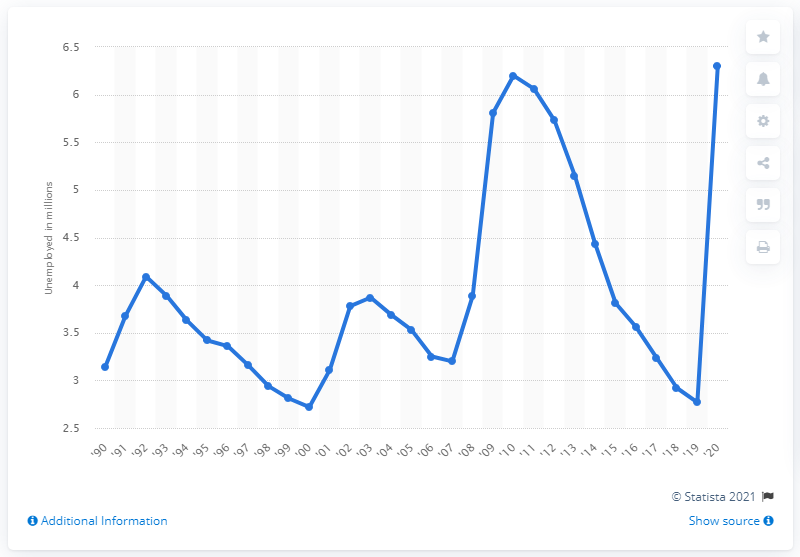Outline some significant characteristics in this image. In 2020, the average number of women seeking employment was 6.06. 